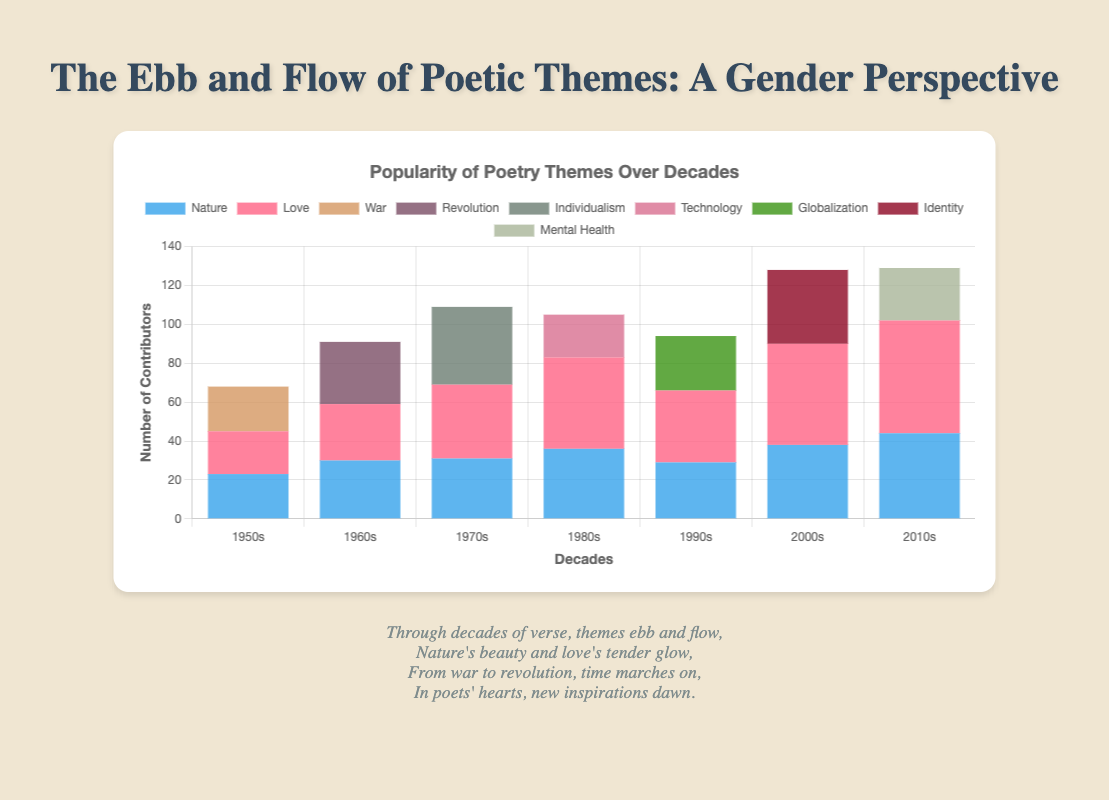What theme had the most contributors in the 1950s? According to the chart, count the total number of contributors for each theme in the 1950s by summing up the male and female contributors. "War" has the highest total with 23 contributors (20 males + 3 females).
Answer: War Which decade saw the highest number of female contributors to the theme of "Love"? Compare the female contributors to "Love" in each decade. The 2010s had the highest with 30 female contributors.
Answer: 2010s How did the popularity of the theme "Nature" among male contributors change from the 1950s to the 2010s? Look at the male contributors for "Nature" in each decade. The numbers are 15 (1950s), 18 (1960s), 17 (1970s), 20 (1980s), 14 (1990s), 20 (2000s), and 21 (2010s). The popularity fluctuated but increased overall from 15 to 21 contributors.
Answer: Increased How many themes in total had more female than male contributors in any decade? Examine each theme in each decade and count how many themes had more female than male contributors. Only two themes, "Love" in the 1970s (20 females vs. 18 males) and "Love" in the 2010s (30 females vs. 28 males), fit this criterion. In total, that is 2 themes.
Answer: 2 themes Which decade featured the smallest overall number of contributors across all themes? Sum the total contributors (both male and female) for each decade across all themes. Compare the sums: 1950s (68), 1960s (91), 1970s (109), 1980s (105), 1990s (94), 2000s (128), 2010s (150). The 1950s had the smallest total with 68 contributors.
Answer: 1950s 